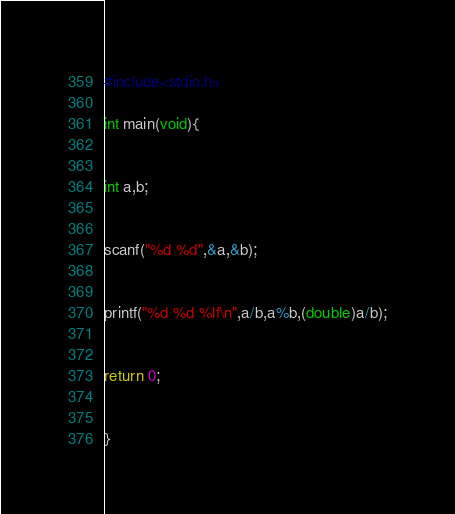<code> <loc_0><loc_0><loc_500><loc_500><_C_>#include<stdio.h>

int main(void){


int a,b;


scanf("%d %d",&a,&b);


printf("%d %d %lf\n",a/b,a%b,(double)a/b);


return 0;


}</code> 